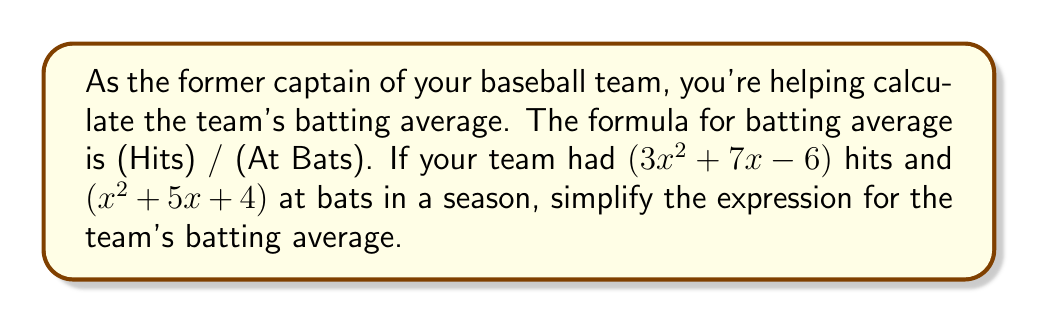What is the answer to this math problem? To simplify the expression for the team's batting average, we need to divide the number of hits by the number of at bats:

$$ \text{Batting Average} = \frac{\text{Hits}}{\text{At Bats}} = \frac{3x^2 + 7x - 6}{x^2 + 5x + 4} $$

Let's simplify this fraction by factoring both the numerator and denominator:

1) Factor the numerator:
   $3x^2 + 7x - 6 = (3x-2)(x+3)$

2) Factor the denominator:
   $x^2 + 5x + 4 = (x+1)(x+4)$

3) Now our expression looks like this:
   $$ \frac{(3x-2)(x+3)}{(x+1)(x+4)} $$

4) There are no common factors between the numerator and denominator, so this is the simplest form of the expression.
Answer: $\frac{(3x-2)(x+3)}{(x+1)(x+4)}$ 